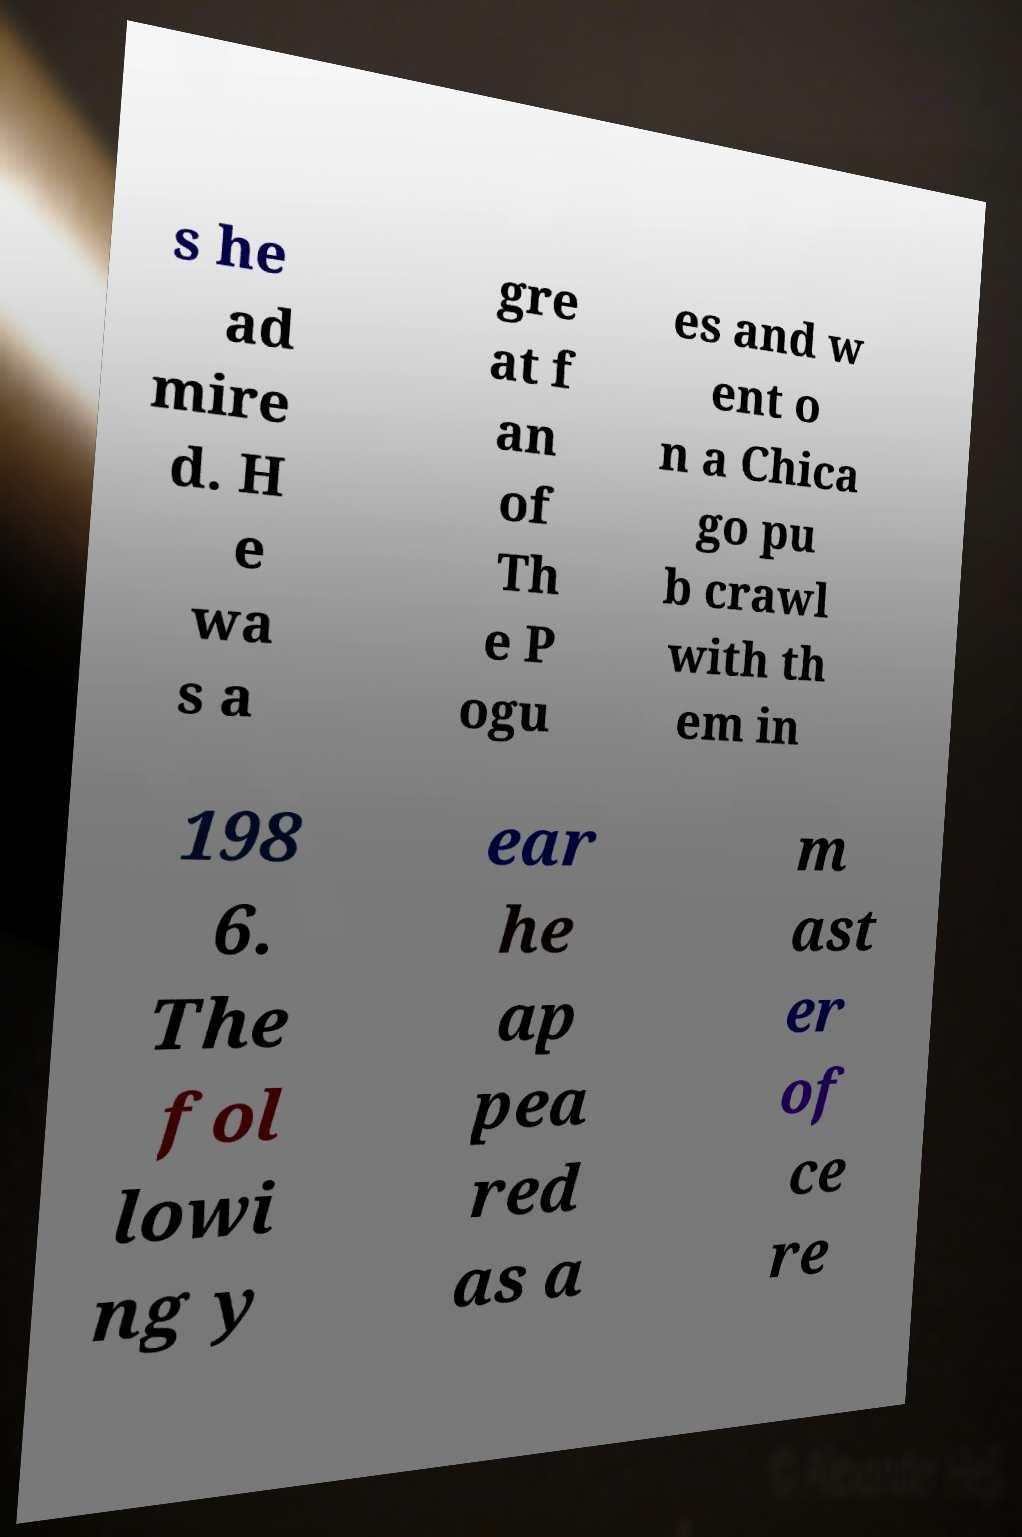Can you read and provide the text displayed in the image?This photo seems to have some interesting text. Can you extract and type it out for me? s he ad mire d. H e wa s a gre at f an of Th e P ogu es and w ent o n a Chica go pu b crawl with th em in 198 6. The fol lowi ng y ear he ap pea red as a m ast er of ce re 